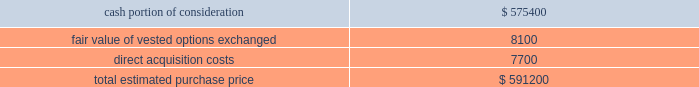Hologic , inc .
Notes to consolidated financial statements ( continued ) ( in thousands , except per share data ) 3 .
Business combinations fiscal 2008 acquisitions : acquisition of third wave technologies , inc .
On july 24 , 2008 the company completed its acquisition of third wave technologies , inc .
( 201cthird wave 201d ) pursuant to a definitive agreement dated june 8 , 2008 .
The company has concluded that the acquisition of third wave does not represent a material business combination and therefore no pro forma financial information has been provided herein .
Subsequent to the acquisition date , the company 2019s results of operations include the results of third wave , which has been reported as a component of the company 2019s diagnostics reporting segment .
Third wave , located in madison , wisconsin , develops and markets molecular diagnostic reagents for a wide variety of dna and rna analysis applications based on its proprietary invader chemistry .
Third wave 2019s current clinical diagnostic offerings consist of products for conditions such as cystic fibrosis , hepatitis c , cardiovascular risk and other diseases .
Third wave recently submitted to the u.s .
Food and drug administration ( 201cfda 201d ) pre-market approval ( 201cpma 201d ) applications for two human papillomavirus ( 201chpv 201d ) tests .
The company paid $ 11.25 per share of third wave , for an aggregate purchase price of approximately $ 591200 ( subject to adjustment ) consisting of approximately $ 575400 in cash in exchange for stock and warrants ; approximately 668 of fully vested stock options granted to third wave employees in exchange for their vested third wave stock options , with an estimated fair value of approximately $ 8100 ; and approximately $ 7700 for acquisition related fees and expenses .
There are no potential contingent consideration arrangements payable to the former shareholders in connection with this transaction .
Additionally , the company granted approximately 315 unvested stock options in exchange for unvested third wave stock options , with an estimated fair value of approximately $ 5100 , which will be recognized as compensation expense over the vesting period .
The company determined the fair value of the options issued in connection with the acquisition in accordance with eitf issue no .
99-12 , determination of the measurement date for the market price of acquirer securities issued in a purchase business combination 201d ) .
The company determined the measurement date to be july 24 , 2008 , the date the transaction was completed , as the number of shares to be issued according to the exchange ratio was not fixed until this date .
The company valued the securities based on the average market price for two days before the measurement date and the measurement date itself .
The weighted average stock price was determined to be approximately $ 23.54 .
The preliminary purchase price is as follows: .

What portion of the estimated purchase price is recorded as acquisition cost? 
Computations: (7700 / 591200)
Answer: 0.01302. 